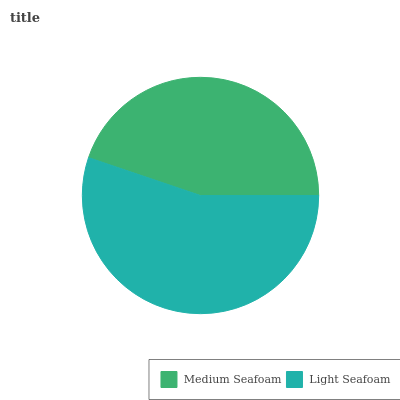Is Medium Seafoam the minimum?
Answer yes or no. Yes. Is Light Seafoam the maximum?
Answer yes or no. Yes. Is Light Seafoam the minimum?
Answer yes or no. No. Is Light Seafoam greater than Medium Seafoam?
Answer yes or no. Yes. Is Medium Seafoam less than Light Seafoam?
Answer yes or no. Yes. Is Medium Seafoam greater than Light Seafoam?
Answer yes or no. No. Is Light Seafoam less than Medium Seafoam?
Answer yes or no. No. Is Light Seafoam the high median?
Answer yes or no. Yes. Is Medium Seafoam the low median?
Answer yes or no. Yes. Is Medium Seafoam the high median?
Answer yes or no. No. Is Light Seafoam the low median?
Answer yes or no. No. 